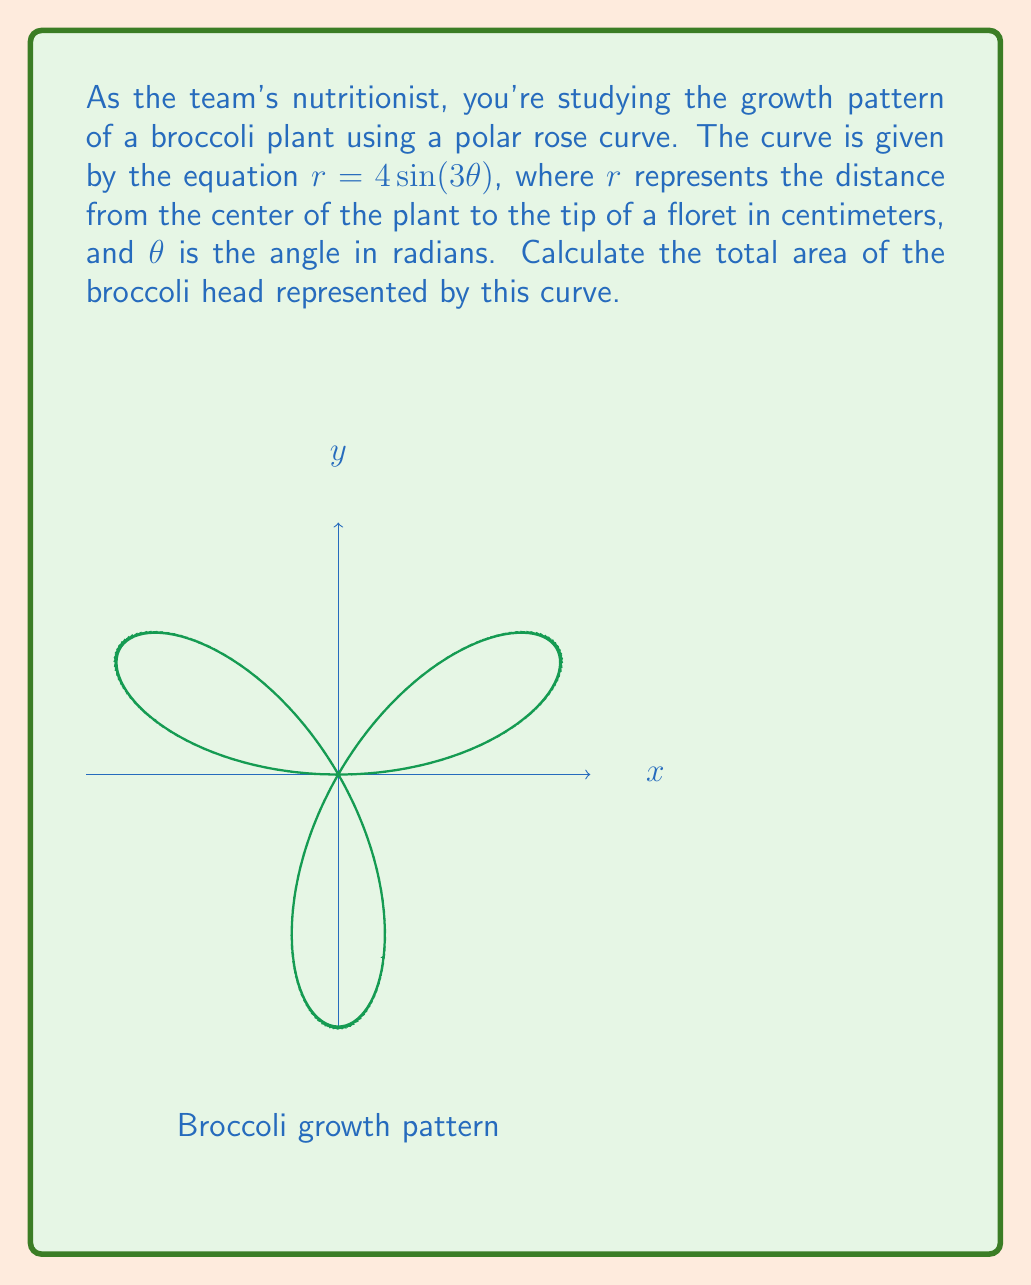Can you solve this math problem? Let's approach this step-by-step:

1) The area of a polar rose curve is given by the formula:

   $$A = \frac{n}{2} \int_0^{2\pi/n} r^2 d\theta$$

   where $n$ is the number of petals.

2) In our equation $r = 4\sin(3\theta)$, the number of petals is determined by the coefficient of $\theta$. When it's odd (as in this case, 3), the number of petals is twice this value. So, $n = 2 * 3 = 6$.

3) Let's substitute our $r$ into the area formula:

   $$A = \frac{6}{2} \int_0^{2\pi/6} (4\sin(3\theta))^2 d\theta$$

4) Simplify:

   $$A = 3 \int_0^{\pi/3} 16\sin^2(3\theta) d\theta$$

5) Use the trigonometric identity $\sin^2 x = \frac{1 - \cos(2x)}{2}$:

   $$A = 3 \int_0^{\pi/3} 16 \cdot \frac{1 - \cos(6\theta)}{2} d\theta$$

6) Simplify:

   $$A = 24 \int_0^{\pi/3} (1 - \cos(6\theta)) d\theta$$

7) Integrate:

   $$A = 24 [\theta - \frac{1}{6}\sin(6\theta)]_0^{\pi/3}$$

8) Evaluate the integral:

   $$A = 24 [(\frac{\pi}{3} - \frac{1}{6}\sin(2\pi)) - (0 - 0)]$$

9) Simplify:

   $$A = 24 \cdot \frac{\pi}{3} = 8\pi$$

Therefore, the total area of the broccoli head is $8\pi$ square centimeters.
Answer: $8\pi$ cm² 